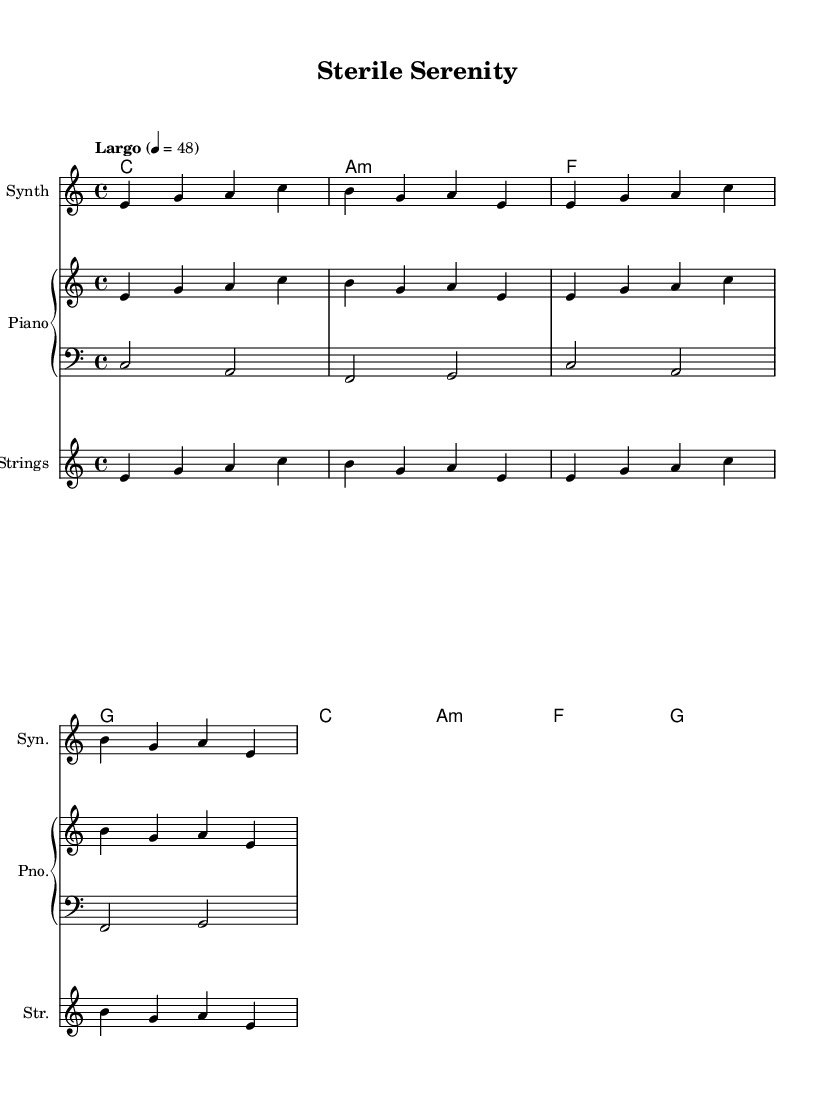What is the key signature of this music? The key signature is C major, which has no sharps or flats.
Answer: C major What is the time signature of the piece? The time signature shown in the music is 4/4, indicating there are four beats in each measure.
Answer: 4/4 What is the tempo marking for this piece? The tempo marking indicates "Largo," suggesting a slow pace, with a metronome mark of 48 beats per minute.
Answer: Largo How many measures are present in the sheet music? Counting the measures, there are a total of four measures shown in the score.
Answer: Four Which instrument is annotated as "Syn." in the sheet music? The instrument labelled as "Syn." represents a synthesizer, as indicated in the staff naming.
Answer: Synth What chord progression is used in the harmonies? The chord progression in the harmonies is C, A minor, F, G, repeated over the measures.
Answer: C, A minor, F, G What type of musical composition is this piece considered? This composition is categorized as a soundtrack, specifically designed as an ambient soundscape inspired by hospital environments.
Answer: Soundtrack 